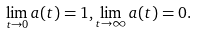<formula> <loc_0><loc_0><loc_500><loc_500>\lim _ { t \to 0 } a ( t ) = 1 , \lim _ { t \to \infty } a ( t ) = 0 .</formula> 